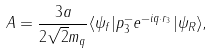Convert formula to latex. <formula><loc_0><loc_0><loc_500><loc_500>A = \frac { 3 a } { 2 \sqrt { 2 } m _ { q } } \langle \psi _ { f } | p ^ { - } _ { 3 } e ^ { - i { q } \cdot { r } _ { 3 } } | \psi _ { R } \rangle ,</formula> 